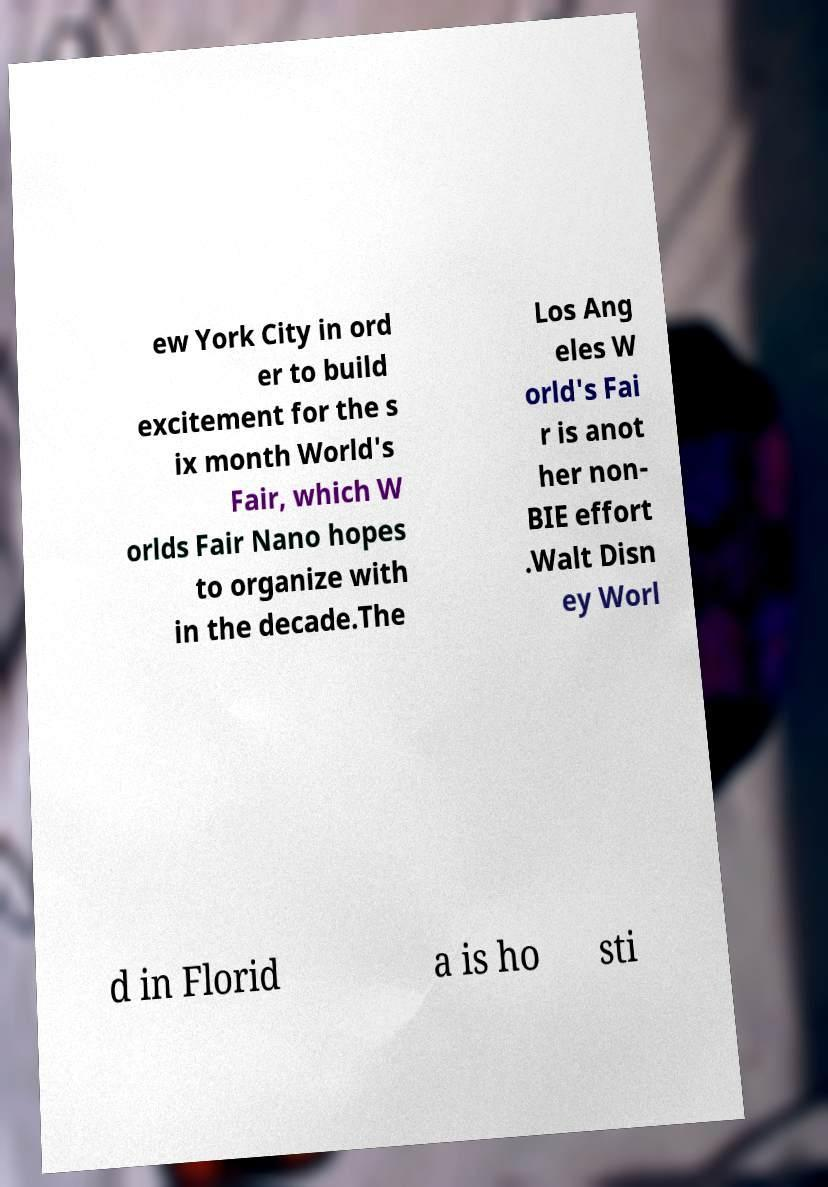Please identify and transcribe the text found in this image. ew York City in ord er to build excitement for the s ix month World's Fair, which W orlds Fair Nano hopes to organize with in the decade.The Los Ang eles W orld's Fai r is anot her non- BIE effort .Walt Disn ey Worl d in Florid a is ho sti 